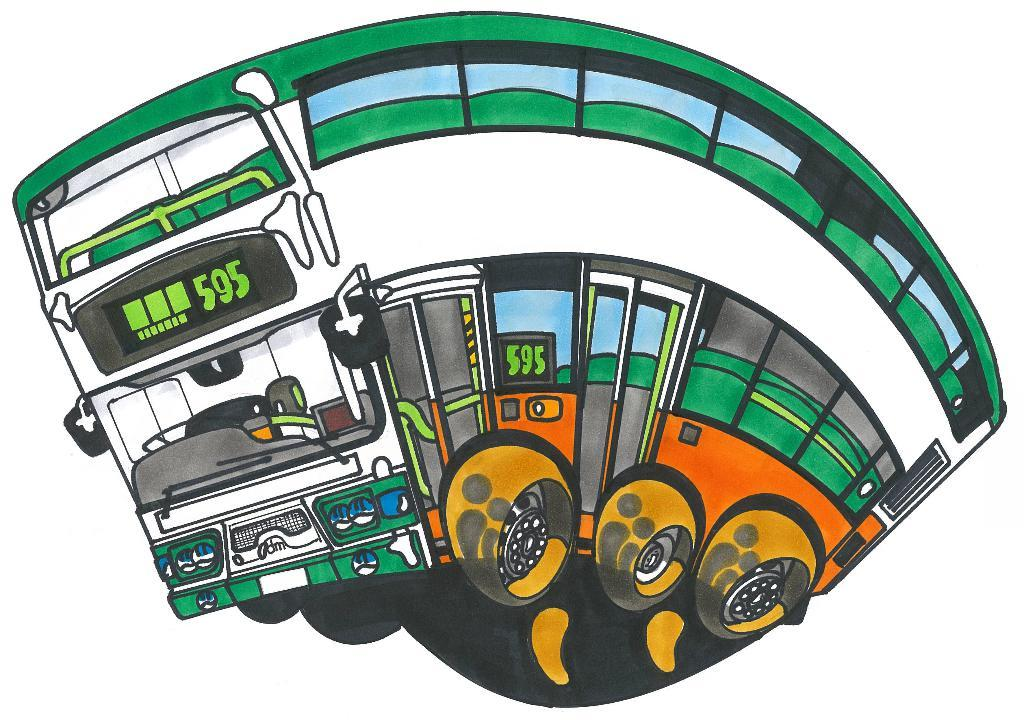What type of artwork is depicted in the image? The image is a painting. What mode of transportation can be seen in the painting? There is a bus in the painting. What type of shirt is the crime wearing in the painting? There is no crime or person wearing a shirt in the painting; it only features a bus. 